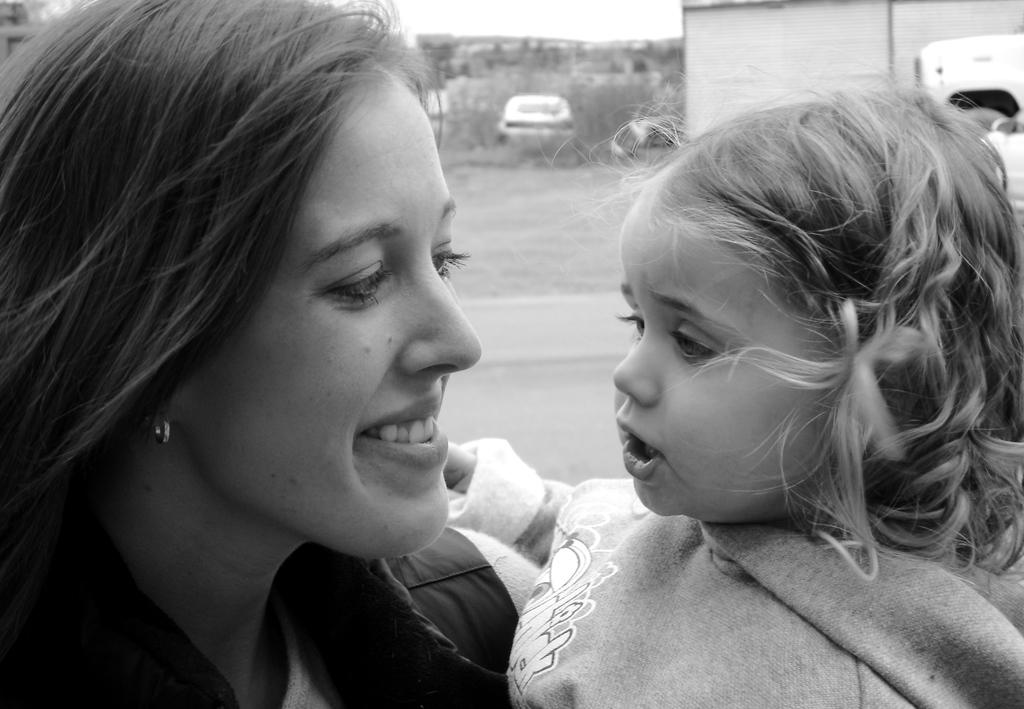How many people are in the image? There are two persons in the image. What type of structure is visible in the image? There is a house in the image. What else can be seen in the image besides the house? There are vehicles, trees, plants, and a sky visible in the image. What type of pathway is present in the image? There is a road in the image. What type of iron is being used by the persons in the image? There is no iron present in the image, and the persons are not using any iron. What historical event is being depicted in the image? The image does not depict any historical event; it shows a house, two persons, vehicles, trees, plants, a sky, and a road. 